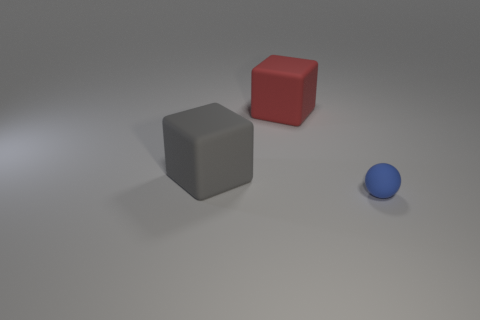Add 2 big brown cylinders. How many objects exist? 5 Subtract all blocks. How many objects are left? 1 Subtract all big blocks. Subtract all small things. How many objects are left? 0 Add 2 big red objects. How many big red objects are left? 3 Add 1 tiny blue rubber objects. How many tiny blue rubber objects exist? 2 Subtract 0 gray balls. How many objects are left? 3 